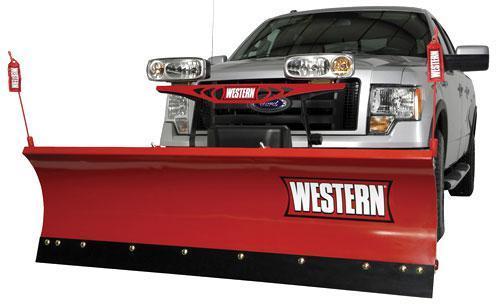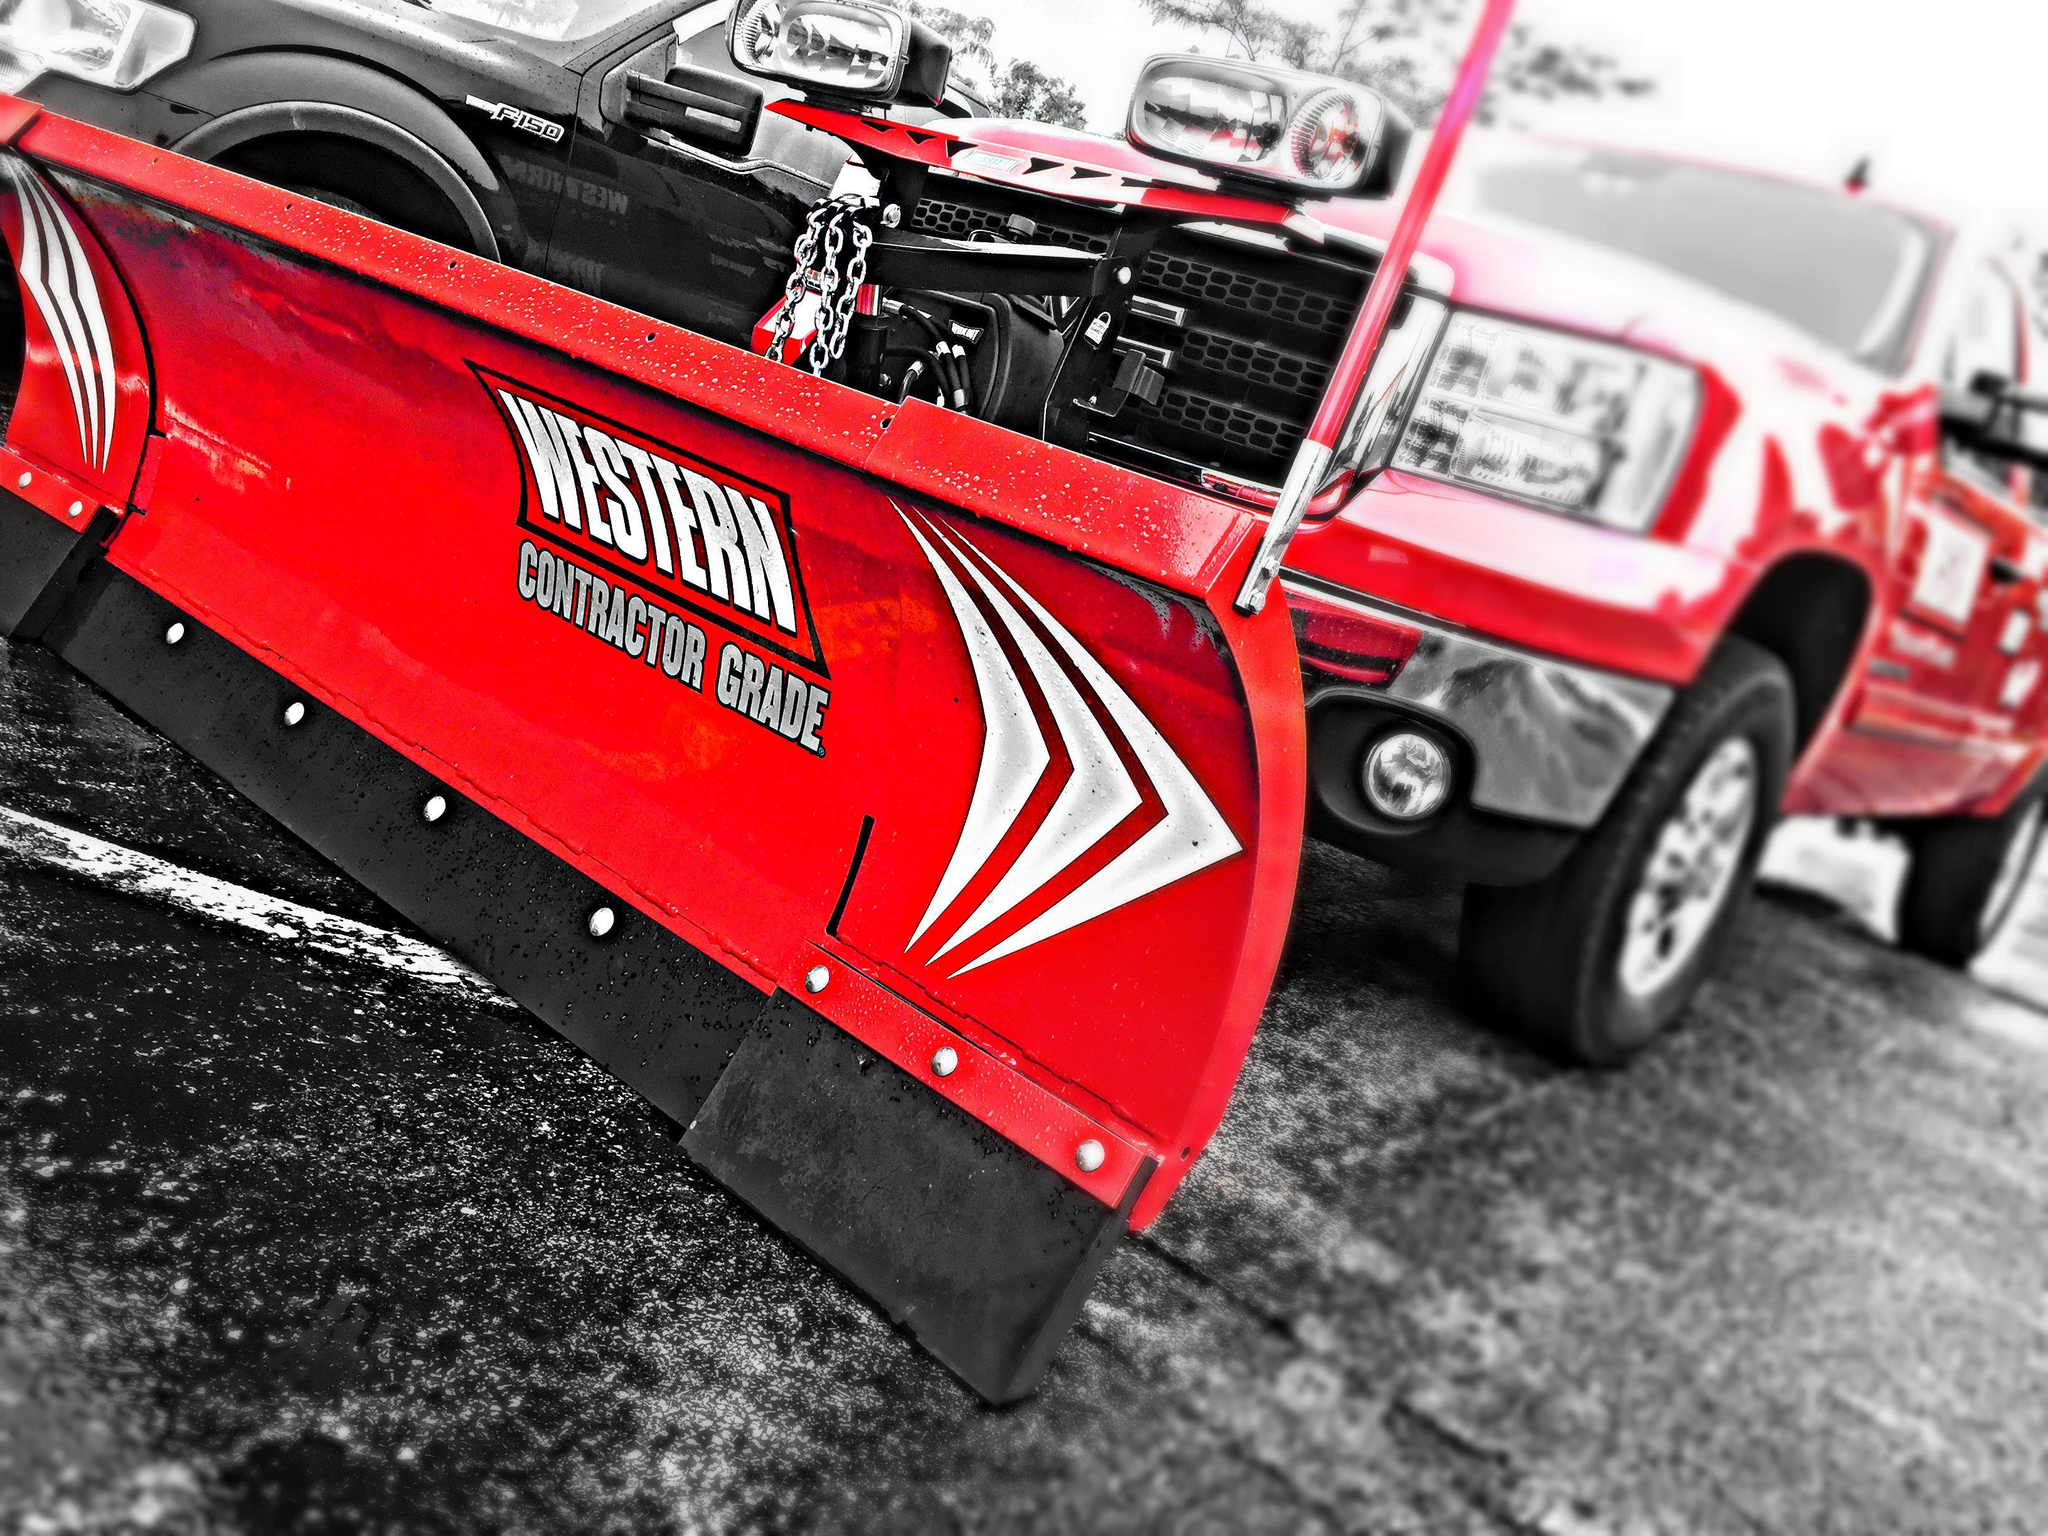The first image is the image on the left, the second image is the image on the right. For the images shown, is this caption "In each image, a snow plow blade is shown with a pickup truck." true? Answer yes or no. Yes. 